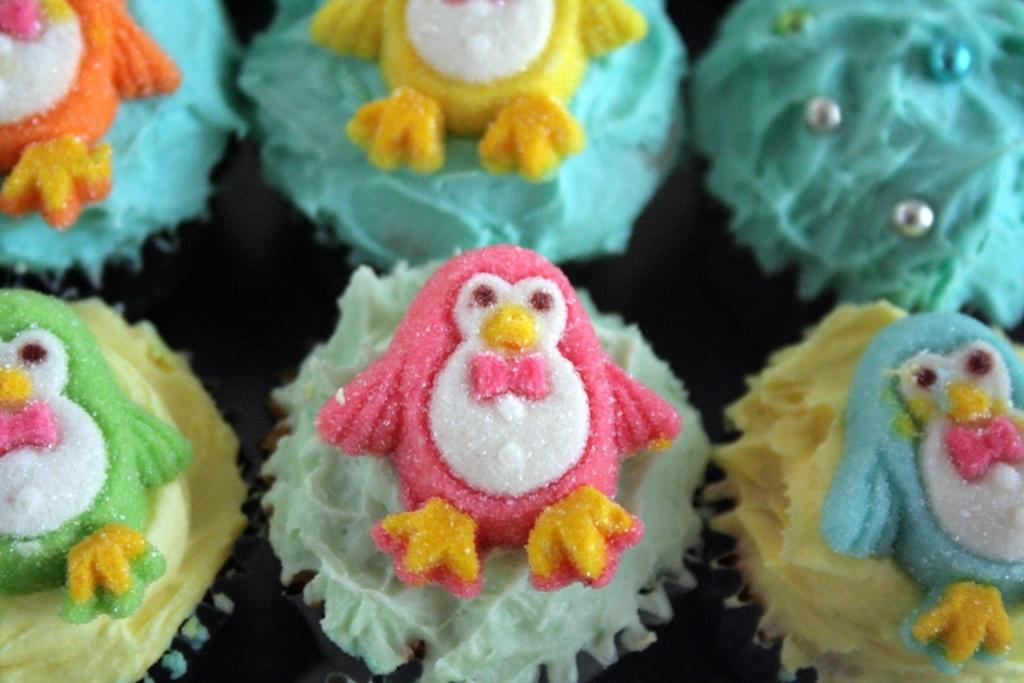How many cupcakes are visible in the image? There are six cupcakes in the image. What colors can be seen among the cupcakes? The cupcakes are in green, blue, and yellow colors. What type of hospital is depicted in the image? There is no hospital present in the image; it features six cupcakes in green, blue, and yellow colors. 